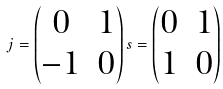Convert formula to latex. <formula><loc_0><loc_0><loc_500><loc_500>j = \begin{pmatrix} 0 & 1 \\ - 1 & 0 \end{pmatrix} s = \begin{pmatrix} 0 & 1 \\ 1 & 0 \end{pmatrix}</formula> 